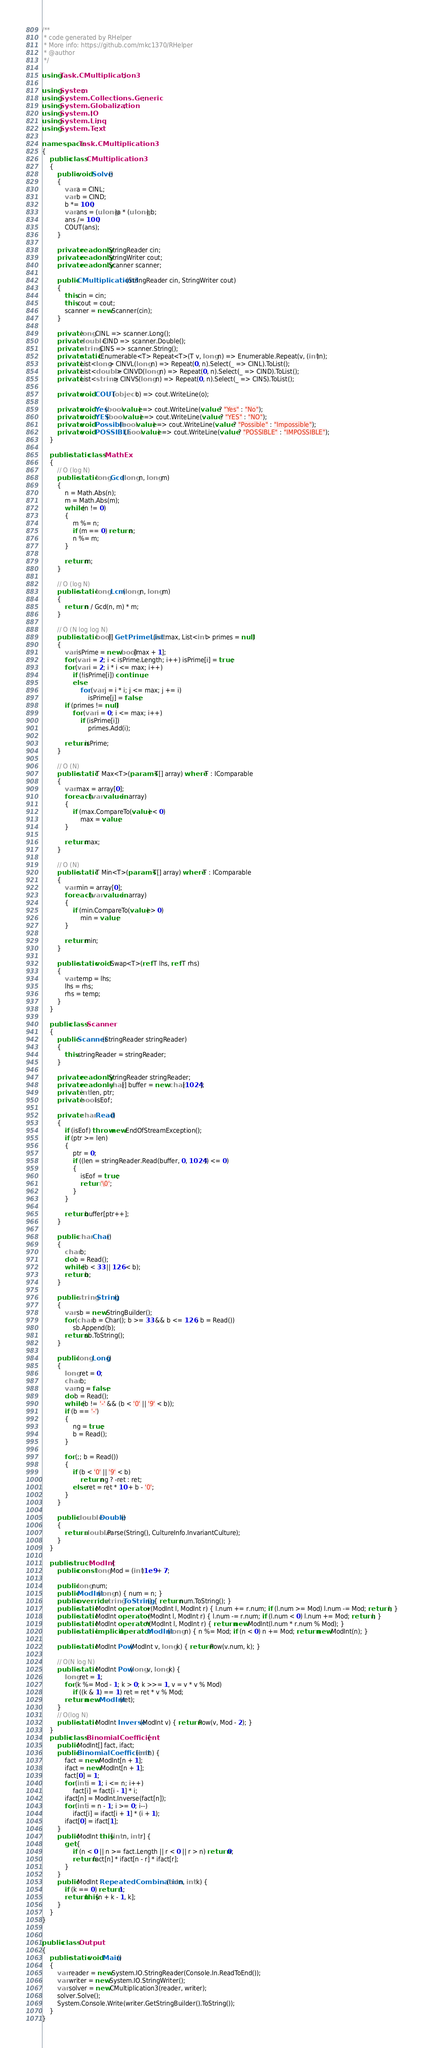Convert code to text. <code><loc_0><loc_0><loc_500><loc_500><_C#_>/**
 * code generated by RHelper
 * More info: https://github.com/mkc1370/RHelper
 * @author 
 */

using Task.CMultiplication3;

using System;
using System.Collections.Generic;
using System.Globalization;
using System.IO;
using System.Linq;
using System.Text;

namespace Task.CMultiplication3
{
    public class CMultiplication3
    {
        public void Solve()
        {
            var a = CINL;
            var b = CIND;
            b *= 100;
            var ans = (ulong)a * (ulong) b;
            ans /= 100;
            COUT(ans);
        }
        
        private readonly StringReader cin;
        private readonly StringWriter cout;
        private readonly Scanner scanner;

        public CMultiplication3(StringReader cin, StringWriter cout)
        {
            this.cin = cin;
            this.cout = cout;
            scanner = new Scanner(cin);
        }

        private long CINL => scanner.Long();
        private double CIND => scanner.Double();
        private string CINS => scanner.String();
        private static IEnumerable<T> Repeat<T>(T v, long n) => Enumerable.Repeat(v, (int)n);
        private List<long> CINVL(long n) => Repeat(0, n).Select(_ => CINL).ToList();
        private List<double> CINVD(long n) => Repeat(0, n).Select(_ => CIND).ToList();
        private List<string> CINVS(long n) => Repeat(0, n).Select(_ => CINS).ToList();

        private void COUT(object o) => cout.WriteLine(o);
        
        private void Yes(bool value) => cout.WriteLine(value ? "Yes" : "No");
        private void YES(bool value) => cout.WriteLine(value ? "YES" : "NO");
        private void Possible(bool value) => cout.WriteLine(value ? "Possible" : "Impossible");
        private void POSSIBLE(bool value) => cout.WriteLine(value ? "POSSIBLE" : "IMPOSSIBLE");
    }

    public static class MathEx
    {
        // O (log N)
        public static long Gcd(long n, long m)
        {
            n = Math.Abs(n);
            m = Math.Abs(m);
            while (n != 0)
            {
                m %= n;
                if (m == 0) return n;
                n %= m;
            }

            return m;
        }

        // O (log N)
        public static long Lcm(long n, long m)
        {
            return n / Gcd(n, m) * m;
        }

        // O (N log log N)
        public static bool[] GetPrimeList(int max, List<int> primes = null)
        {
            var isPrime = new bool[max + 1];
            for (var i = 2; i < isPrime.Length; i++) isPrime[i] = true;
            for (var i = 2; i * i <= max; i++)
                if (!isPrime[i]) continue;
                else
                    for (var j = i * i; j <= max; j += i)
                        isPrime[j] = false;
            if (primes != null)
                for (var i = 0; i <= max; i++)
                    if (isPrime[i])
                        primes.Add(i);

            return isPrime;
        }

        // O (N)
        public static T Max<T>(params T[] array) where T : IComparable
        {
            var max = array[0];
            foreach (var value in array)
            {
                if (max.CompareTo(value) < 0)
                    max = value;
            }

            return max;
        }

        // O (N)
        public static T Min<T>(params T[] array) where T : IComparable
        {
            var min = array[0];
            foreach (var value in array)
            {
                if (min.CompareTo(value) > 0)
                    min = value;
            }

            return min;
        }

        public static void Swap<T>(ref T lhs, ref T rhs)
        {
            var temp = lhs;
            lhs = rhs;
            rhs = temp;
        }
    }

    public class Scanner
    {
        public Scanner(StringReader stringReader)
        {
            this.stringReader = stringReader;
        }

        private readonly StringReader stringReader;
        private readonly char[] buffer = new char[1024];
        private int len, ptr;
        private bool isEof;

        private char Read()
        {
            if (isEof) throw new EndOfStreamException();
            if (ptr >= len)
            {
                ptr = 0;
                if ((len = stringReader.Read(buffer, 0, 1024)) <= 0)
                {
                    isEof = true;
                    return '\0';
                }
            }

            return buffer[ptr++];
        }

        public char Char()
        {
            char b;
            do b = Read();
            while (b < 33 || 126 < b);
            return b;
        }

        public string String()
        {
            var sb = new StringBuilder();
            for (char b = Char(); b >= 33 && b <= 126; b = Read())
                sb.Append(b);
            return sb.ToString();
        }

        public long Long()
        {
            long ret = 0;
            char b;
            var ng = false;
            do b = Read();
            while (b != '-' && (b < '0' || '9' < b));
            if (b == '-')
            {
                ng = true;
                b = Read();
            }

            for (;; b = Read())
            {
                if (b < '0' || '9' < b)
                    return ng ? -ret : ret;
                else ret = ret * 10 + b - '0';
            }
        }

        public double Double()
        {
            return double.Parse(String(), CultureInfo.InvariantCulture);
        }
    }

    public struct ModInt {
        public const long Mod = (int)1e9 + 7;

        public long num;
        public ModInt(long n) { num = n; }
        public override string ToString() { return num.ToString(); }
        public static ModInt operator +(ModInt l, ModInt r) { l.num += r.num; if (l.num >= Mod) l.num -= Mod; return l; }
        public static ModInt operator -(ModInt l, ModInt r) { l.num -= r.num; if (l.num < 0) l.num += Mod; return l; }
        public static ModInt operator *(ModInt l, ModInt r) { return new ModInt(l.num * r.num % Mod); }
        public static implicit operator ModInt(long n) { n %= Mod; if (n < 0) n += Mod; return new ModInt(n); }

        public static ModInt Pow(ModInt v, long k) { return Pow(v.num, k); }

        // O(N log N)
        public static ModInt Pow(long v, long k) {
            long ret = 1;
            for (k %= Mod - 1; k > 0; k >>= 1, v = v * v % Mod)
                if ((k & 1) == 1) ret = ret * v % Mod;
            return new ModInt(ret);
        }
        // O(log N)
        public static ModInt Inverse(ModInt v) { return Pow(v, Mod - 2); }
    }
    public class BinomialCoefficient {
        public ModInt[] fact, ifact;
        public BinomialCoefficient(int n) {
            fact = new ModInt[n + 1];
            ifact = new ModInt[n + 1];
            fact[0] = 1;
            for (int i = 1; i <= n; i++)
                fact[i] = fact[i - 1] * i;
            ifact[n] = ModInt.Inverse(fact[n]);
            for (int i = n - 1; i >= 0; i--)
                ifact[i] = ifact[i + 1] * (i + 1);
            ifact[0] = ifact[1];
        }
        public ModInt this[int n, int r] {
            get {
                if (n < 0 || n >= fact.Length || r < 0 || r > n) return 0;
                return fact[n] * ifact[n - r] * ifact[r];
            }
        }
        public ModInt RepeatedCombination(int n, int k) {
            if (k == 0) return 1;
            return this[n + k - 1, k];
        }
    }
}


public class Output
{
	public static void Main()
	{
		var reader = new System.IO.StringReader(Console.In.ReadToEnd());
		var writer = new System.IO.StringWriter();
		var solver = new CMultiplication3(reader, writer);
		solver.Solve();
		System.Console.Write(writer.GetStringBuilder().ToString());
	}
}
</code> 